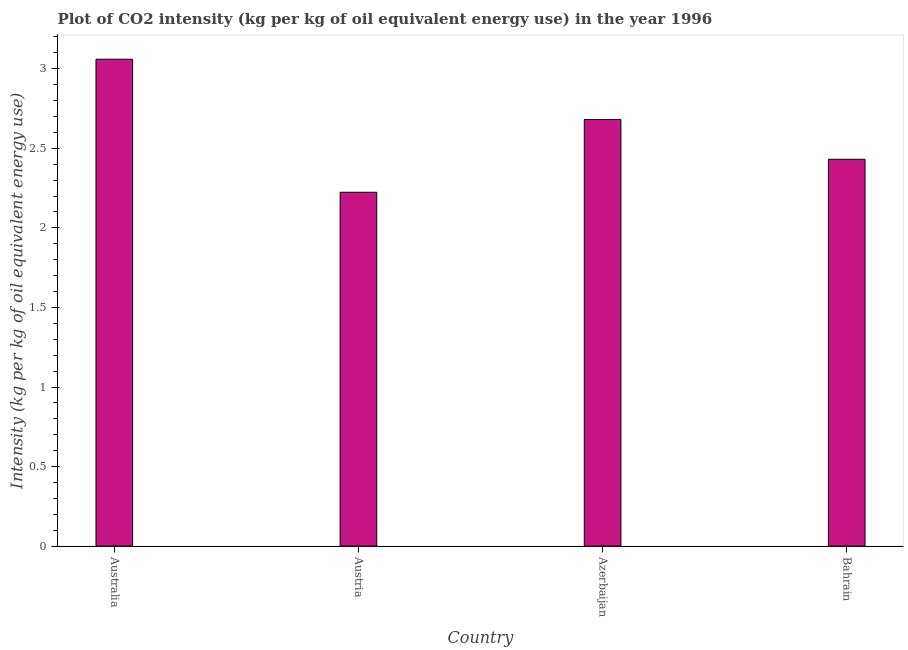Does the graph contain grids?
Your answer should be compact. No. What is the title of the graph?
Keep it short and to the point. Plot of CO2 intensity (kg per kg of oil equivalent energy use) in the year 1996. What is the label or title of the Y-axis?
Provide a short and direct response. Intensity (kg per kg of oil equivalent energy use). What is the co2 intensity in Azerbaijan?
Provide a succinct answer. 2.68. Across all countries, what is the maximum co2 intensity?
Offer a very short reply. 3.06. Across all countries, what is the minimum co2 intensity?
Give a very brief answer. 2.22. In which country was the co2 intensity maximum?
Keep it short and to the point. Australia. In which country was the co2 intensity minimum?
Ensure brevity in your answer.  Austria. What is the sum of the co2 intensity?
Give a very brief answer. 10.4. What is the difference between the co2 intensity in Austria and Azerbaijan?
Provide a succinct answer. -0.46. What is the average co2 intensity per country?
Make the answer very short. 2.6. What is the median co2 intensity?
Your answer should be compact. 2.56. What is the ratio of the co2 intensity in Austria to that in Azerbaijan?
Your answer should be compact. 0.83. What is the difference between the highest and the second highest co2 intensity?
Make the answer very short. 0.38. Is the sum of the co2 intensity in Austria and Bahrain greater than the maximum co2 intensity across all countries?
Keep it short and to the point. Yes. What is the difference between the highest and the lowest co2 intensity?
Your answer should be compact. 0.84. In how many countries, is the co2 intensity greater than the average co2 intensity taken over all countries?
Make the answer very short. 2. What is the Intensity (kg per kg of oil equivalent energy use) in Australia?
Your answer should be compact. 3.06. What is the Intensity (kg per kg of oil equivalent energy use) of Austria?
Your answer should be compact. 2.22. What is the Intensity (kg per kg of oil equivalent energy use) of Azerbaijan?
Ensure brevity in your answer.  2.68. What is the Intensity (kg per kg of oil equivalent energy use) of Bahrain?
Your response must be concise. 2.43. What is the difference between the Intensity (kg per kg of oil equivalent energy use) in Australia and Austria?
Make the answer very short. 0.84. What is the difference between the Intensity (kg per kg of oil equivalent energy use) in Australia and Azerbaijan?
Offer a terse response. 0.38. What is the difference between the Intensity (kg per kg of oil equivalent energy use) in Australia and Bahrain?
Give a very brief answer. 0.63. What is the difference between the Intensity (kg per kg of oil equivalent energy use) in Austria and Azerbaijan?
Give a very brief answer. -0.46. What is the difference between the Intensity (kg per kg of oil equivalent energy use) in Austria and Bahrain?
Your answer should be very brief. -0.21. What is the difference between the Intensity (kg per kg of oil equivalent energy use) in Azerbaijan and Bahrain?
Ensure brevity in your answer.  0.25. What is the ratio of the Intensity (kg per kg of oil equivalent energy use) in Australia to that in Austria?
Provide a succinct answer. 1.38. What is the ratio of the Intensity (kg per kg of oil equivalent energy use) in Australia to that in Azerbaijan?
Provide a succinct answer. 1.14. What is the ratio of the Intensity (kg per kg of oil equivalent energy use) in Australia to that in Bahrain?
Provide a succinct answer. 1.26. What is the ratio of the Intensity (kg per kg of oil equivalent energy use) in Austria to that in Azerbaijan?
Provide a succinct answer. 0.83. What is the ratio of the Intensity (kg per kg of oil equivalent energy use) in Austria to that in Bahrain?
Offer a terse response. 0.92. What is the ratio of the Intensity (kg per kg of oil equivalent energy use) in Azerbaijan to that in Bahrain?
Provide a short and direct response. 1.1. 